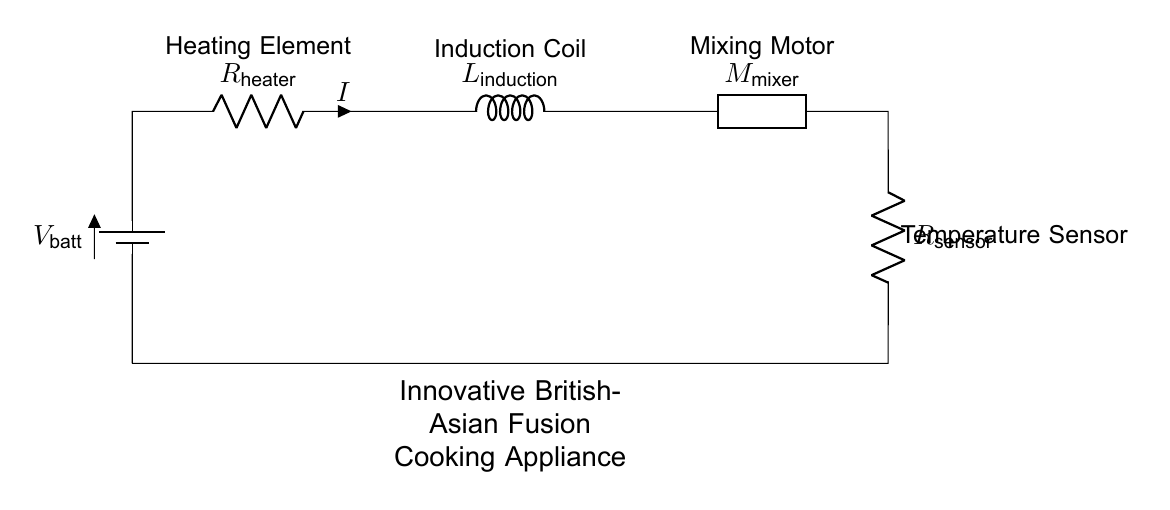What is the main voltage source in this circuit? The main voltage source is the battery, indicated as V_batt, which supplies power to the entire circuit.
Answer: battery How many resistors are present in the circuit? There are two resistors in the circuit: the heater (R_heater) and the sensor (R_sensor).
Answer: two What component is responsible for mixing the ingredients? The mixing motor (designated as M_mixer) is responsible for mixing the ingredients in the cooking appliance.
Answer: mixing motor What is likely the role of the induction coil in this circuit? The induction coil (L_induction) is likely used to generate heat for cooking by inducing a current that produces heat through magnetic fields.
Answer: generate heat What is the relationship between the heating element and the temperature sensor in terms of circuit function? The heating element heats the cooking ingredients, and the temperature sensor monitors the heat to ensure proper cooking temperatures, enabling temperature control.
Answer: temperature control What type of circuit is depicted here? The circuit is a series circuit, as all components are connected end-to-end in a single path for current flow.
Answer: series circuit 